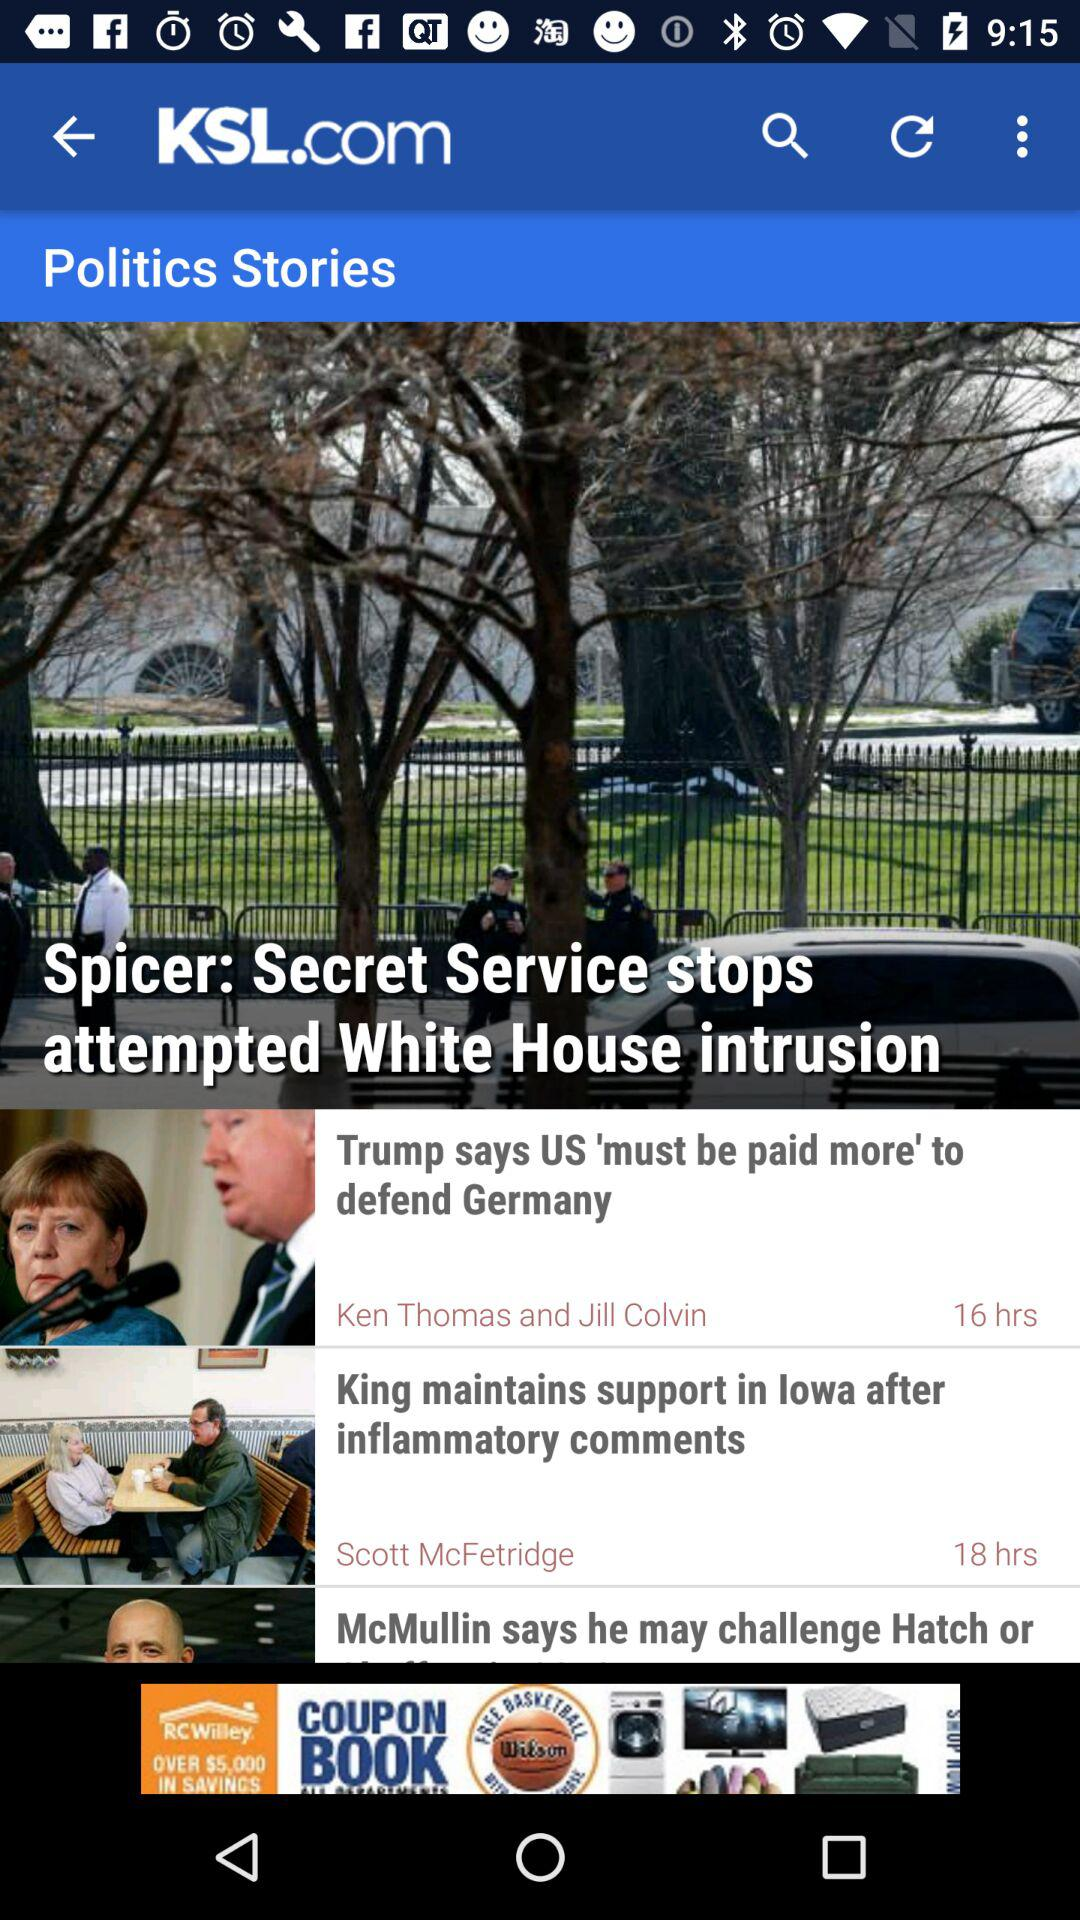What is the headline? The headlines are "Spicer: Secret Service stops attempted White House intrusion", "Trump says US 'must be paid more' to defend Germany" and "King maintains support in lowa after inflammatory comments". 